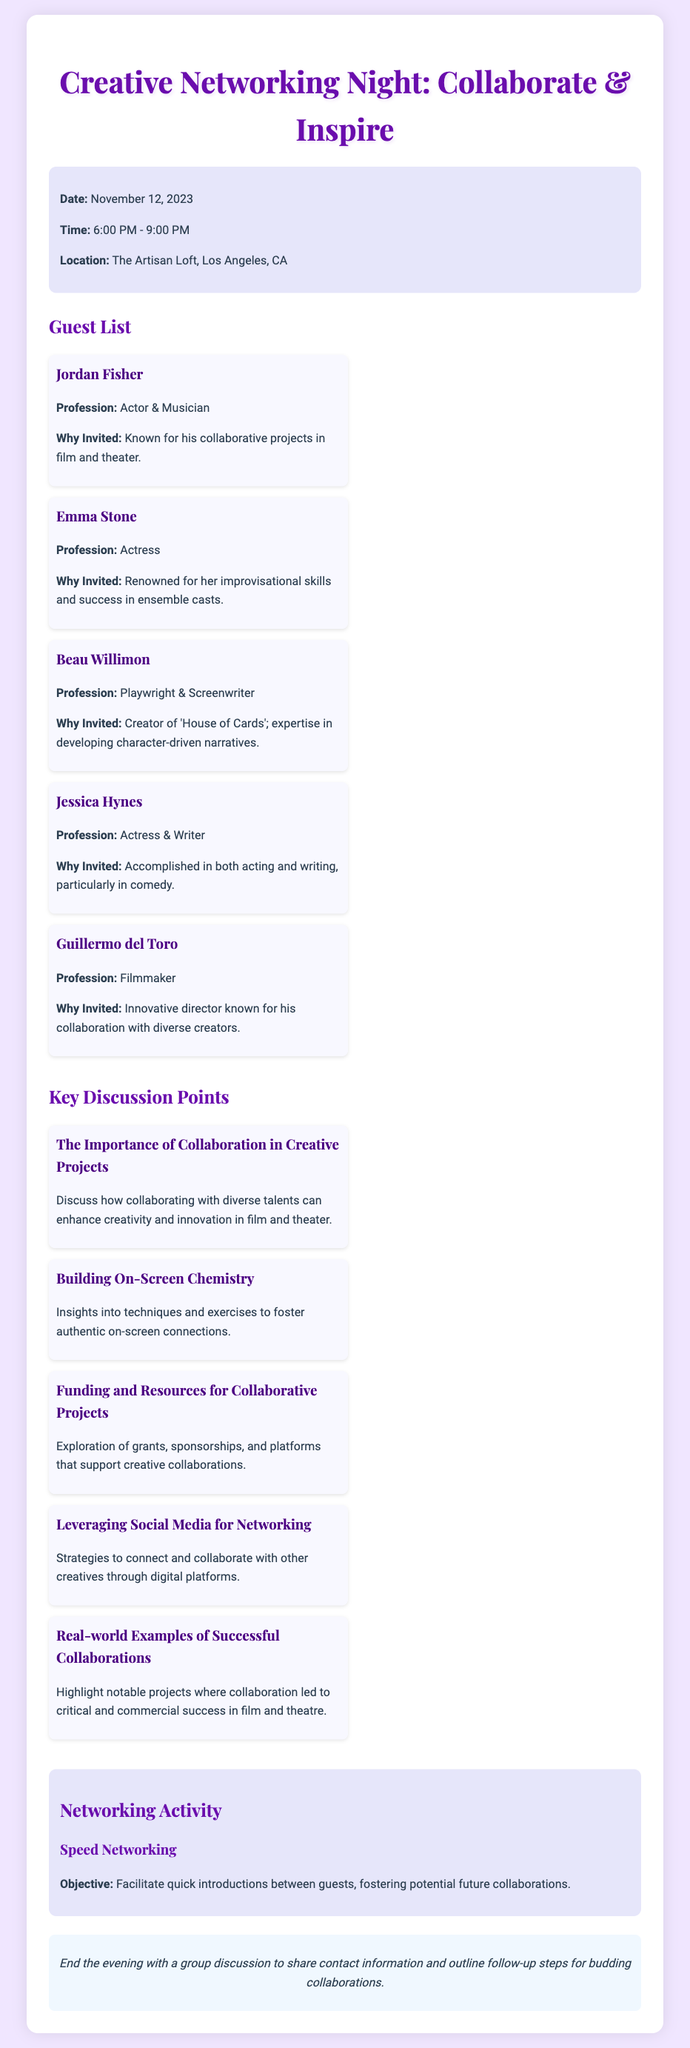What is the date of the event? The date of the event is mentioned in the event details section of the document as November 12, 2023.
Answer: November 12, 2023 Who is the first guest listed? The first guest is identified in the guest list section of the document, which starts with Jordan Fisher.
Answer: Jordan Fisher What is the location of the event? The location of the event is stated clearly in the event details as The Artisan Loft, Los Angeles, CA.
Answer: The Artisan Loft, Los Angeles, CA What is one key discussion point mentioned? One of the key discussion points can be found in the discussion points section, and one listed is "The Importance of Collaboration in Creative Projects."
Answer: The Importance of Collaboration in Creative Projects What is the objective of the networking activity? The objective of the networking activity is specified in the networking activity section as facilitating quick introductions between guests, fostering potential future collaborations.
Answer: Facilitate quick introductions How long is the event scheduled to last? The event time listed indicates the event lasts from 6:00 PM to 9:00 PM, which totals three hours.
Answer: Three hours Who is recognized for their improvisational skills? Emma Stone is specifically mentioned in the guest list for her renowned improvisational skills.
Answer: Emma Stone Which profession is Beau Willimon associated with? The document describes Beau Willimon as a Playwright & Screenwriter in the guest list section.
Answer: Playwright & Screenwriter What is the theme of the networking night? The theme of the night is stated in the title of the document as "Collaborate & Inspire."
Answer: Collaborate & Inspire 